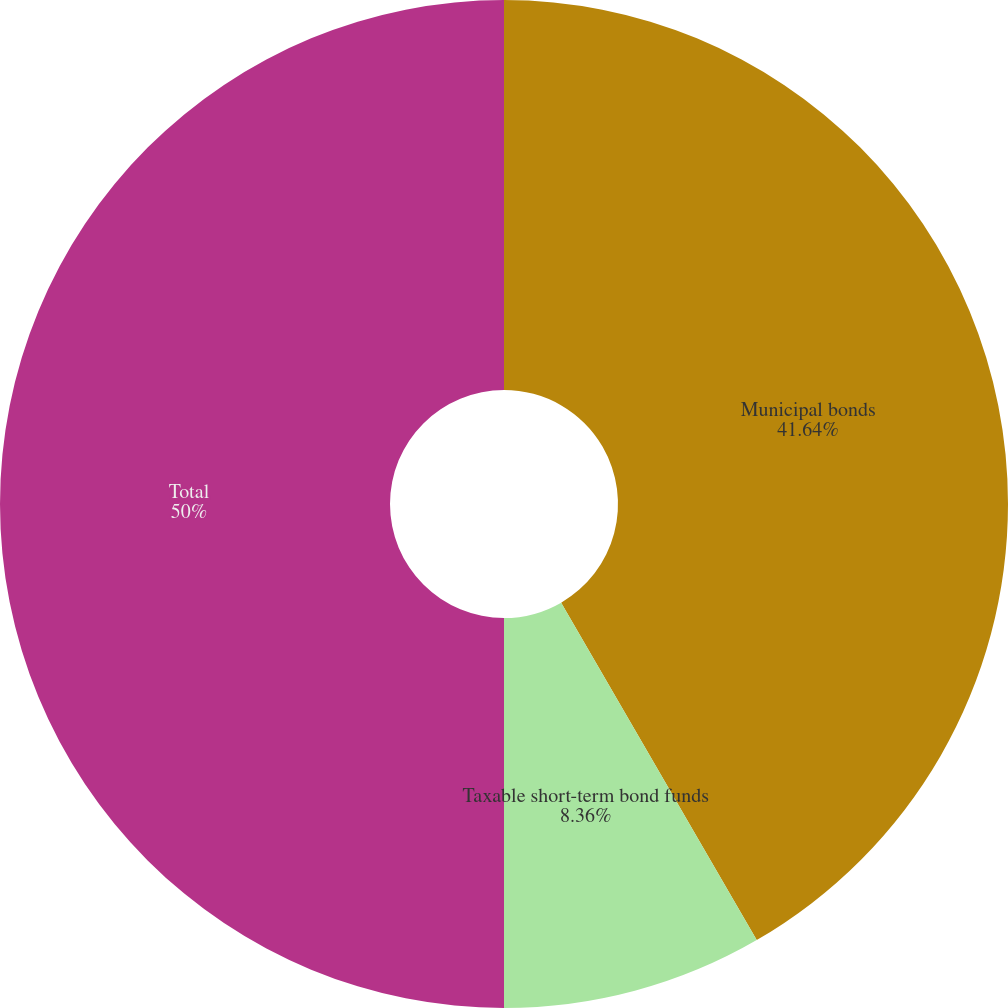<chart> <loc_0><loc_0><loc_500><loc_500><pie_chart><fcel>Municipal bonds<fcel>Taxable short-term bond funds<fcel>Total<nl><fcel>41.64%<fcel>8.36%<fcel>50.0%<nl></chart> 